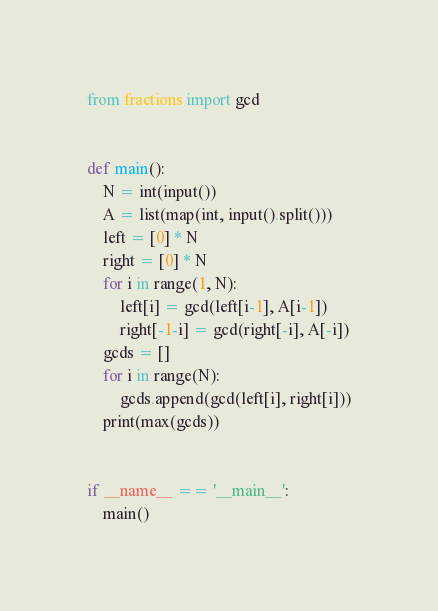Convert code to text. <code><loc_0><loc_0><loc_500><loc_500><_Python_>from fractions import gcd


def main():
    N = int(input())
    A = list(map(int, input().split()))
    left = [0] * N
    right = [0] * N
    for i in range(1, N):
        left[i] = gcd(left[i-1], A[i-1])
        right[-1-i] = gcd(right[-i], A[-i])
    gcds = []
    for i in range(N):
        gcds.append(gcd(left[i], right[i]))
    print(max(gcds))


if __name__ == '__main__':
    main()
</code> 